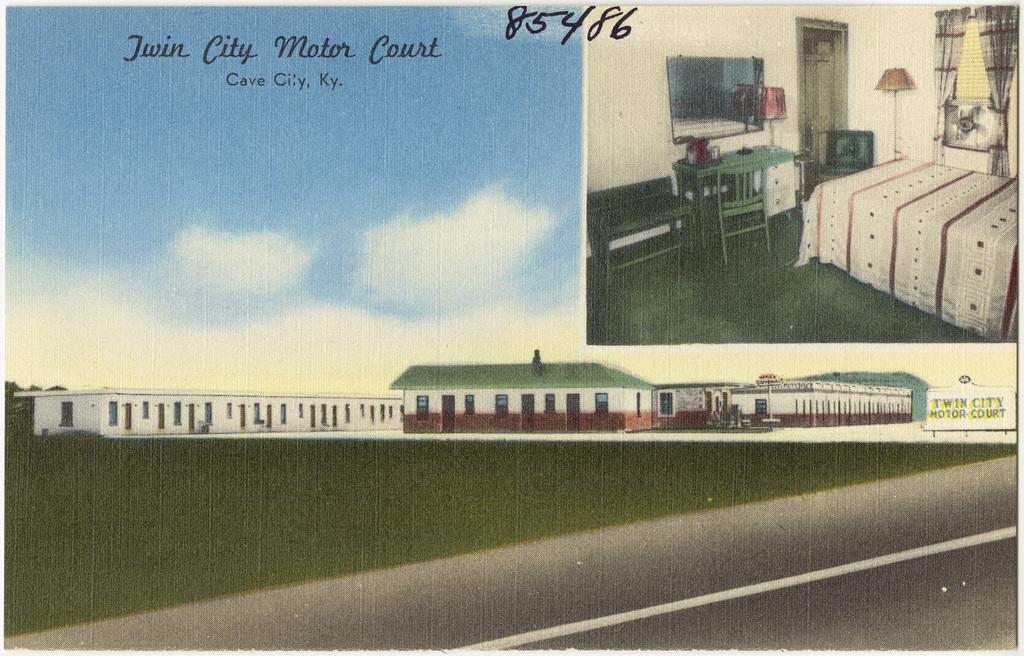What type of visual is the image? The image is a poster. What can be found on the poster? There is information on the poster. What can be seen in the background of the image? The sky is visible in the image, as well as a building. What architectural features are present in the image? A road, a television, a chair, a desk, a bed, and curtains are present in the image. What is on the bed in the image? A mattress is on the bed. What type of window treatment is present in the image? Curtains are present in the image. What other objects can be seen in the image? There are various objects in the image. What color is the ink used to write on the stocking in the image? There is no stocking or ink present in the image. How does the image depict the vastness of space? The image does not depict space; it is a poster with information and various objects in a room setting. 